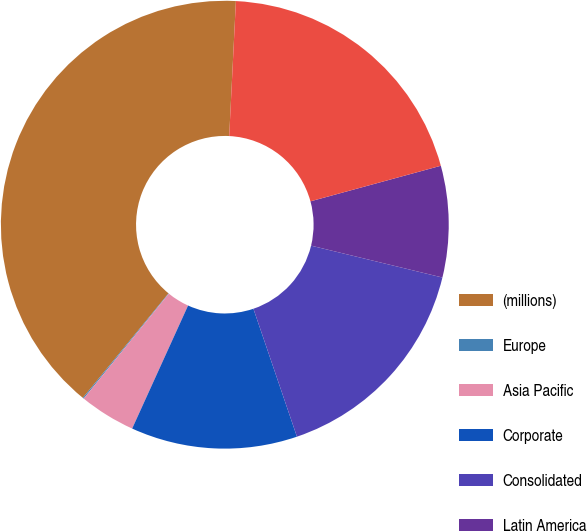<chart> <loc_0><loc_0><loc_500><loc_500><pie_chart><fcel>(millions)<fcel>Europe<fcel>Asia Pacific<fcel>Corporate<fcel>Consolidated<fcel>Latin America<fcel>Corporate & North America<nl><fcel>39.86%<fcel>0.08%<fcel>4.06%<fcel>12.01%<fcel>15.99%<fcel>8.03%<fcel>19.97%<nl></chart> 